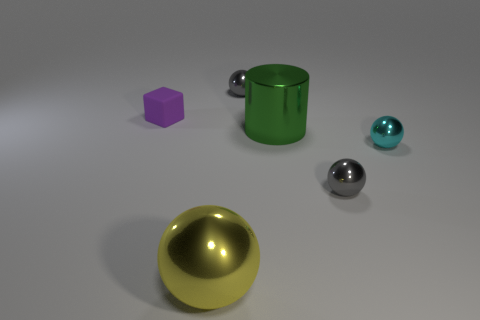Add 2 large yellow things. How many objects exist? 8 Subtract all red spheres. Subtract all brown cylinders. How many spheres are left? 4 Subtract all cylinders. How many objects are left? 5 Add 5 large objects. How many large objects exist? 7 Subtract 0 green blocks. How many objects are left? 6 Subtract all small shiny things. Subtract all tiny gray metal spheres. How many objects are left? 1 Add 3 big shiny cylinders. How many big shiny cylinders are left? 4 